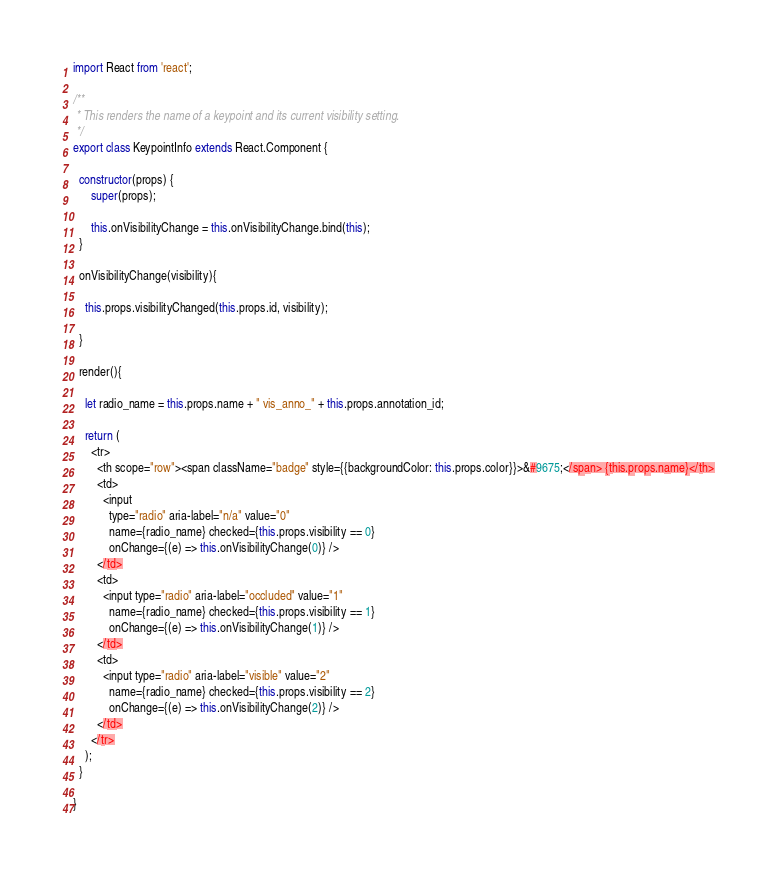Convert code to text. <code><loc_0><loc_0><loc_500><loc_500><_JavaScript_>import React from 'react';

/**
 * This renders the name of a keypoint and its current visibility setting.
 */
export class KeypointInfo extends React.Component {

  constructor(props) {
      super(props);

      this.onVisibilityChange = this.onVisibilityChange.bind(this);
  }

  onVisibilityChange(visibility){

    this.props.visibilityChanged(this.props.id, visibility);

  }

  render(){

    let radio_name = this.props.name + " vis_anno_" + this.props.annotation_id;

    return (
      <tr>
        <th scope="row"><span className="badge" style={{backgroundColor: this.props.color}}>&#9675;</span> {this.props.name}</th>
        <td>
          <input
            type="radio" aria-label="n/a" value="0"
            name={radio_name} checked={this.props.visibility == 0}
            onChange={(e) => this.onVisibilityChange(0)} />
        </td>
        <td>
          <input type="radio" aria-label="occluded" value="1"
            name={radio_name} checked={this.props.visibility == 1}
            onChange={(e) => this.onVisibilityChange(1)} />
        </td>
        <td>
          <input type="radio" aria-label="visible" value="2"
            name={radio_name} checked={this.props.visibility == 2}
            onChange={(e) => this.onVisibilityChange(2)} />
        </td>
      </tr>
    );
  }

}</code> 